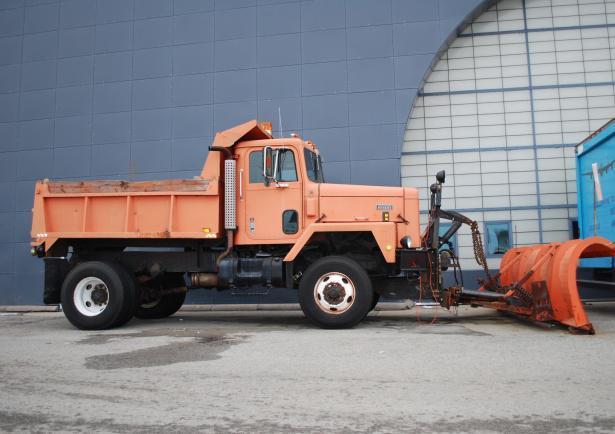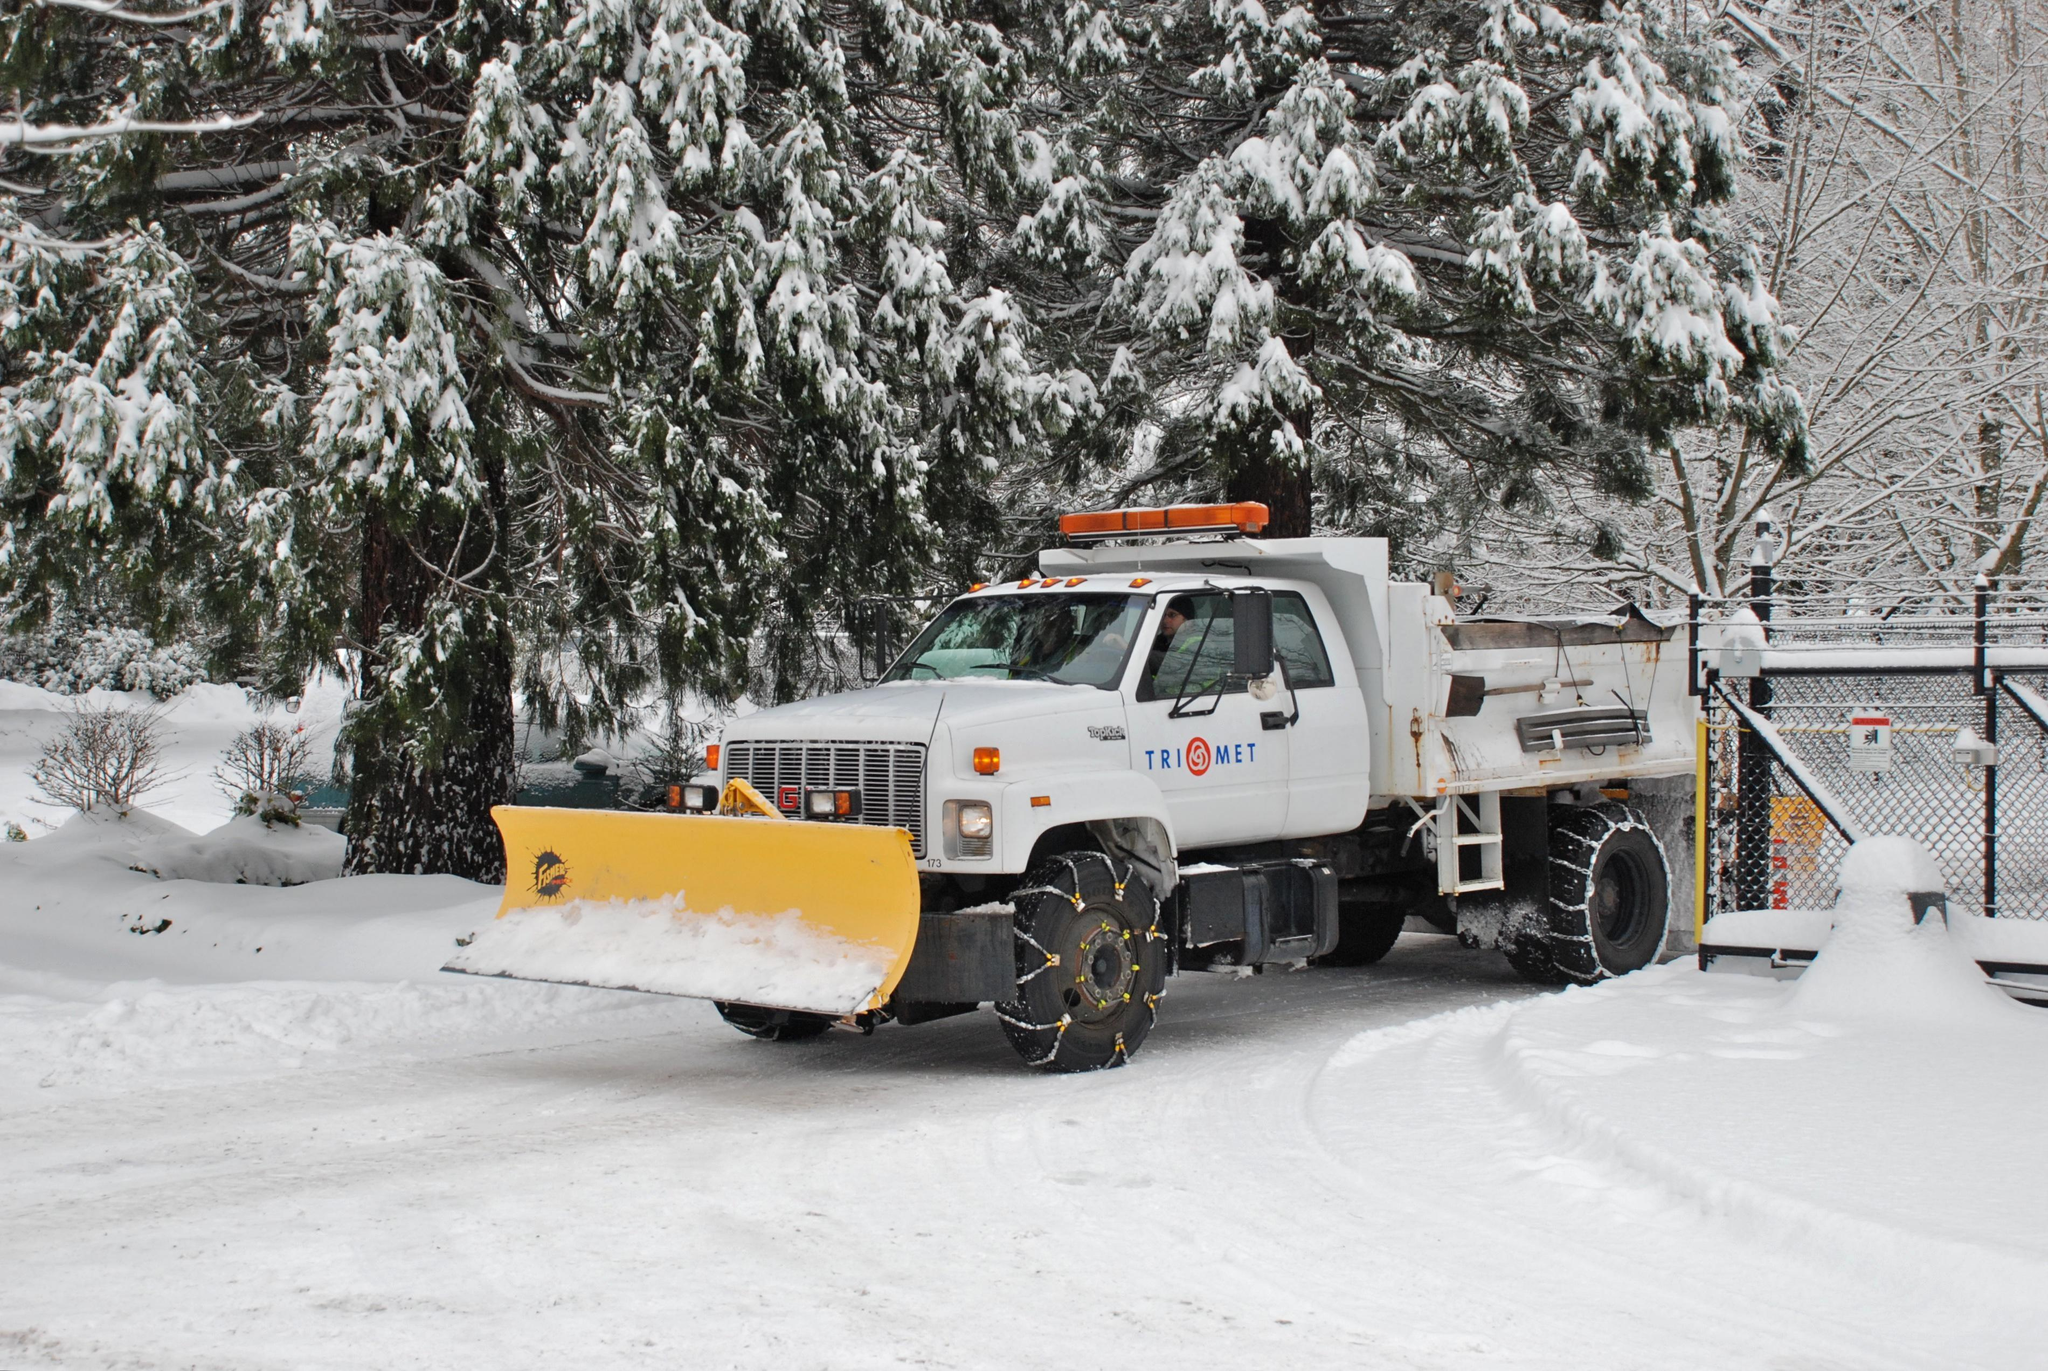The first image is the image on the left, the second image is the image on the right. For the images shown, is this caption "An image features a truck with an orange plow and orange cab on a non-snowy surface." true? Answer yes or no. Yes. The first image is the image on the left, the second image is the image on the right. Assess this claim about the two images: "In one image, a white truck with snow blade is in a snowy area near trees, while a second image shows an orange truck with an angled orange blade.". Correct or not? Answer yes or no. Yes. 